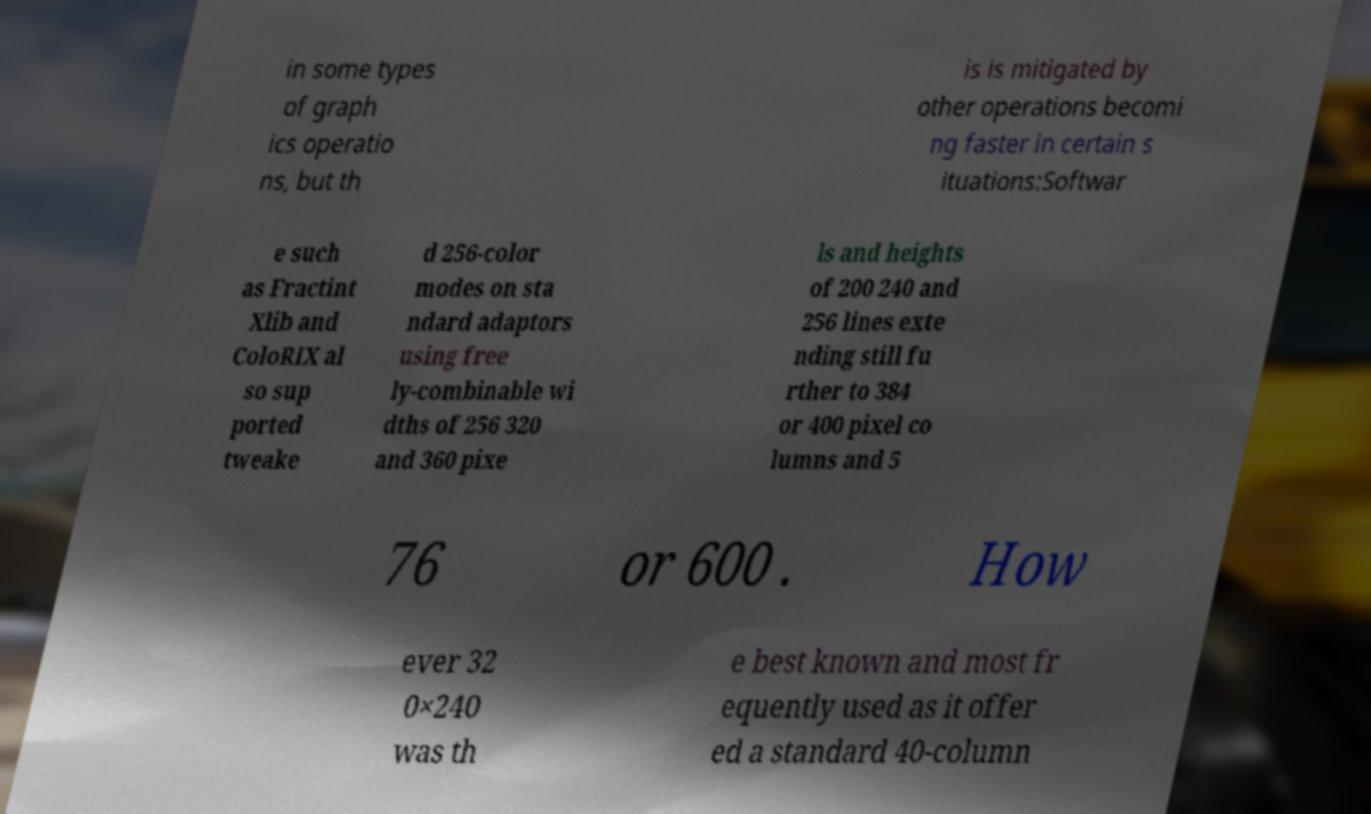For documentation purposes, I need the text within this image transcribed. Could you provide that? in some types of graph ics operatio ns, but th is is mitigated by other operations becomi ng faster in certain s ituations:Softwar e such as Fractint Xlib and ColoRIX al so sup ported tweake d 256-color modes on sta ndard adaptors using free ly-combinable wi dths of 256 320 and 360 pixe ls and heights of 200 240 and 256 lines exte nding still fu rther to 384 or 400 pixel co lumns and 5 76 or 600 . How ever 32 0×240 was th e best known and most fr equently used as it offer ed a standard 40-column 